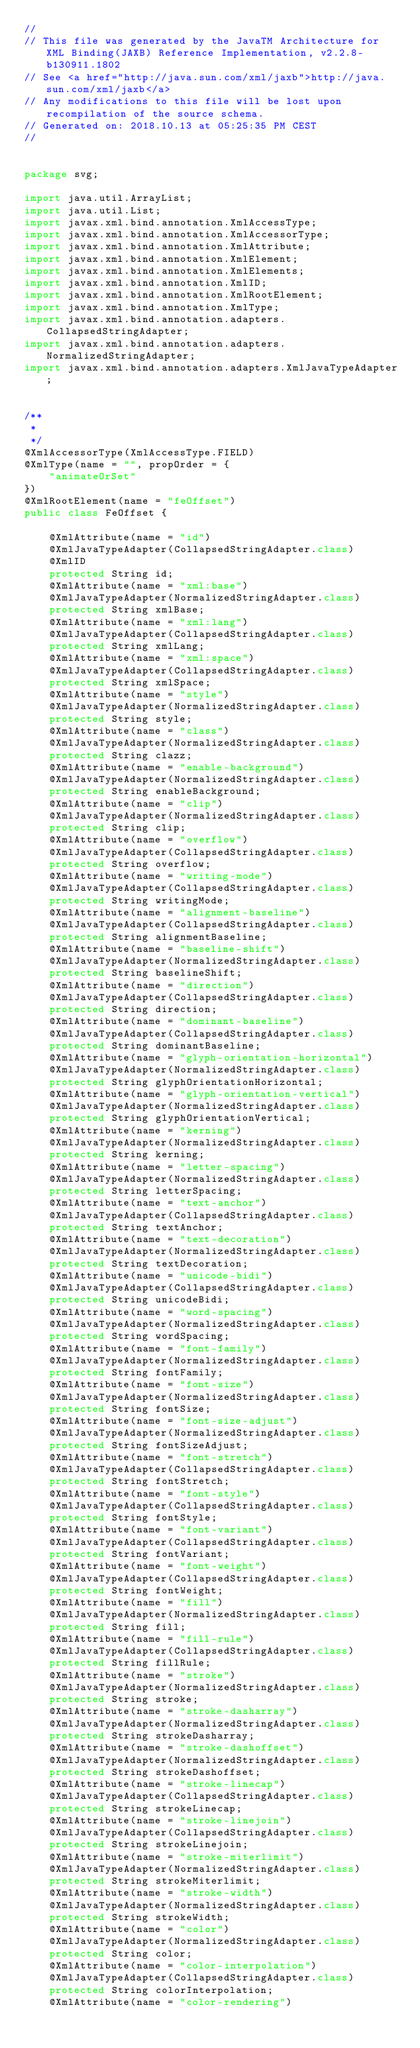Convert code to text. <code><loc_0><loc_0><loc_500><loc_500><_Java_>//
// This file was generated by the JavaTM Architecture for XML Binding(JAXB) Reference Implementation, v2.2.8-b130911.1802 
// See <a href="http://java.sun.com/xml/jaxb">http://java.sun.com/xml/jaxb</a> 
// Any modifications to this file will be lost upon recompilation of the source schema. 
// Generated on: 2018.10.13 at 05:25:35 PM CEST 
//


package svg;

import java.util.ArrayList;
import java.util.List;
import javax.xml.bind.annotation.XmlAccessType;
import javax.xml.bind.annotation.XmlAccessorType;
import javax.xml.bind.annotation.XmlAttribute;
import javax.xml.bind.annotation.XmlElement;
import javax.xml.bind.annotation.XmlElements;
import javax.xml.bind.annotation.XmlID;
import javax.xml.bind.annotation.XmlRootElement;
import javax.xml.bind.annotation.XmlType;
import javax.xml.bind.annotation.adapters.CollapsedStringAdapter;
import javax.xml.bind.annotation.adapters.NormalizedStringAdapter;
import javax.xml.bind.annotation.adapters.XmlJavaTypeAdapter;


/**
 * 
 */
@XmlAccessorType(XmlAccessType.FIELD)
@XmlType(name = "", propOrder = {
    "animateOrSet"
})
@XmlRootElement(name = "feOffset")
public class FeOffset {

    @XmlAttribute(name = "id")
    @XmlJavaTypeAdapter(CollapsedStringAdapter.class)
    @XmlID
    protected String id;
    @XmlAttribute(name = "xml:base")
    @XmlJavaTypeAdapter(NormalizedStringAdapter.class)
    protected String xmlBase;
    @XmlAttribute(name = "xml:lang")
    @XmlJavaTypeAdapter(CollapsedStringAdapter.class)
    protected String xmlLang;
    @XmlAttribute(name = "xml:space")
    @XmlJavaTypeAdapter(CollapsedStringAdapter.class)
    protected String xmlSpace;
    @XmlAttribute(name = "style")
    @XmlJavaTypeAdapter(NormalizedStringAdapter.class)
    protected String style;
    @XmlAttribute(name = "class")
    @XmlJavaTypeAdapter(NormalizedStringAdapter.class)
    protected String clazz;
    @XmlAttribute(name = "enable-background")
    @XmlJavaTypeAdapter(NormalizedStringAdapter.class)
    protected String enableBackground;
    @XmlAttribute(name = "clip")
    @XmlJavaTypeAdapter(NormalizedStringAdapter.class)
    protected String clip;
    @XmlAttribute(name = "overflow")
    @XmlJavaTypeAdapter(CollapsedStringAdapter.class)
    protected String overflow;
    @XmlAttribute(name = "writing-mode")
    @XmlJavaTypeAdapter(CollapsedStringAdapter.class)
    protected String writingMode;
    @XmlAttribute(name = "alignment-baseline")
    @XmlJavaTypeAdapter(CollapsedStringAdapter.class)
    protected String alignmentBaseline;
    @XmlAttribute(name = "baseline-shift")
    @XmlJavaTypeAdapter(NormalizedStringAdapter.class)
    protected String baselineShift;
    @XmlAttribute(name = "direction")
    @XmlJavaTypeAdapter(CollapsedStringAdapter.class)
    protected String direction;
    @XmlAttribute(name = "dominant-baseline")
    @XmlJavaTypeAdapter(CollapsedStringAdapter.class)
    protected String dominantBaseline;
    @XmlAttribute(name = "glyph-orientation-horizontal")
    @XmlJavaTypeAdapter(NormalizedStringAdapter.class)
    protected String glyphOrientationHorizontal;
    @XmlAttribute(name = "glyph-orientation-vertical")
    @XmlJavaTypeAdapter(NormalizedStringAdapter.class)
    protected String glyphOrientationVertical;
    @XmlAttribute(name = "kerning")
    @XmlJavaTypeAdapter(NormalizedStringAdapter.class)
    protected String kerning;
    @XmlAttribute(name = "letter-spacing")
    @XmlJavaTypeAdapter(NormalizedStringAdapter.class)
    protected String letterSpacing;
    @XmlAttribute(name = "text-anchor")
    @XmlJavaTypeAdapter(CollapsedStringAdapter.class)
    protected String textAnchor;
    @XmlAttribute(name = "text-decoration")
    @XmlJavaTypeAdapter(NormalizedStringAdapter.class)
    protected String textDecoration;
    @XmlAttribute(name = "unicode-bidi")
    @XmlJavaTypeAdapter(CollapsedStringAdapter.class)
    protected String unicodeBidi;
    @XmlAttribute(name = "word-spacing")
    @XmlJavaTypeAdapter(NormalizedStringAdapter.class)
    protected String wordSpacing;
    @XmlAttribute(name = "font-family")
    @XmlJavaTypeAdapter(NormalizedStringAdapter.class)
    protected String fontFamily;
    @XmlAttribute(name = "font-size")
    @XmlJavaTypeAdapter(NormalizedStringAdapter.class)
    protected String fontSize;
    @XmlAttribute(name = "font-size-adjust")
    @XmlJavaTypeAdapter(NormalizedStringAdapter.class)
    protected String fontSizeAdjust;
    @XmlAttribute(name = "font-stretch")
    @XmlJavaTypeAdapter(CollapsedStringAdapter.class)
    protected String fontStretch;
    @XmlAttribute(name = "font-style")
    @XmlJavaTypeAdapter(CollapsedStringAdapter.class)
    protected String fontStyle;
    @XmlAttribute(name = "font-variant")
    @XmlJavaTypeAdapter(CollapsedStringAdapter.class)
    protected String fontVariant;
    @XmlAttribute(name = "font-weight")
    @XmlJavaTypeAdapter(CollapsedStringAdapter.class)
    protected String fontWeight;
    @XmlAttribute(name = "fill")
    @XmlJavaTypeAdapter(NormalizedStringAdapter.class)
    protected String fill;
    @XmlAttribute(name = "fill-rule")
    @XmlJavaTypeAdapter(CollapsedStringAdapter.class)
    protected String fillRule;
    @XmlAttribute(name = "stroke")
    @XmlJavaTypeAdapter(NormalizedStringAdapter.class)
    protected String stroke;
    @XmlAttribute(name = "stroke-dasharray")
    @XmlJavaTypeAdapter(NormalizedStringAdapter.class)
    protected String strokeDasharray;
    @XmlAttribute(name = "stroke-dashoffset")
    @XmlJavaTypeAdapter(NormalizedStringAdapter.class)
    protected String strokeDashoffset;
    @XmlAttribute(name = "stroke-linecap")
    @XmlJavaTypeAdapter(CollapsedStringAdapter.class)
    protected String strokeLinecap;
    @XmlAttribute(name = "stroke-linejoin")
    @XmlJavaTypeAdapter(CollapsedStringAdapter.class)
    protected String strokeLinejoin;
    @XmlAttribute(name = "stroke-miterlimit")
    @XmlJavaTypeAdapter(NormalizedStringAdapter.class)
    protected String strokeMiterlimit;
    @XmlAttribute(name = "stroke-width")
    @XmlJavaTypeAdapter(NormalizedStringAdapter.class)
    protected String strokeWidth;
    @XmlAttribute(name = "color")
    @XmlJavaTypeAdapter(NormalizedStringAdapter.class)
    protected String color;
    @XmlAttribute(name = "color-interpolation")
    @XmlJavaTypeAdapter(CollapsedStringAdapter.class)
    protected String colorInterpolation;
    @XmlAttribute(name = "color-rendering")</code> 